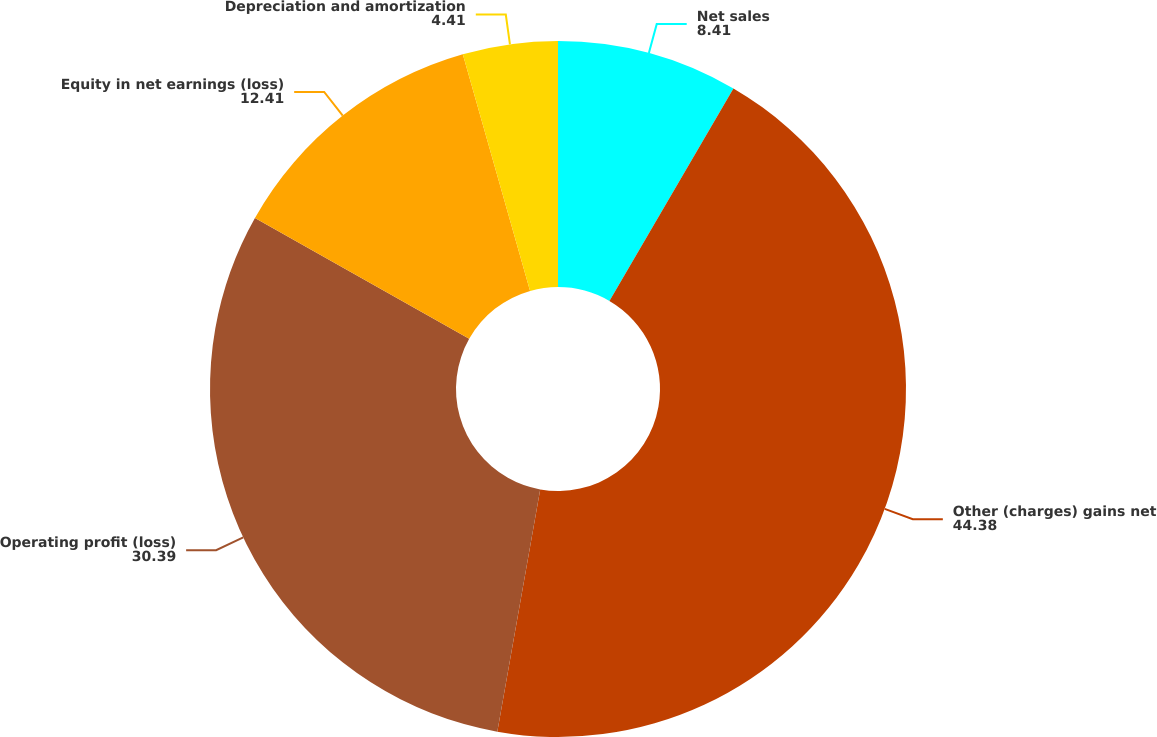Convert chart to OTSL. <chart><loc_0><loc_0><loc_500><loc_500><pie_chart><fcel>Net sales<fcel>Other (charges) gains net<fcel>Operating profit (loss)<fcel>Equity in net earnings (loss)<fcel>Depreciation and amortization<nl><fcel>8.41%<fcel>44.38%<fcel>30.39%<fcel>12.41%<fcel>4.41%<nl></chart> 